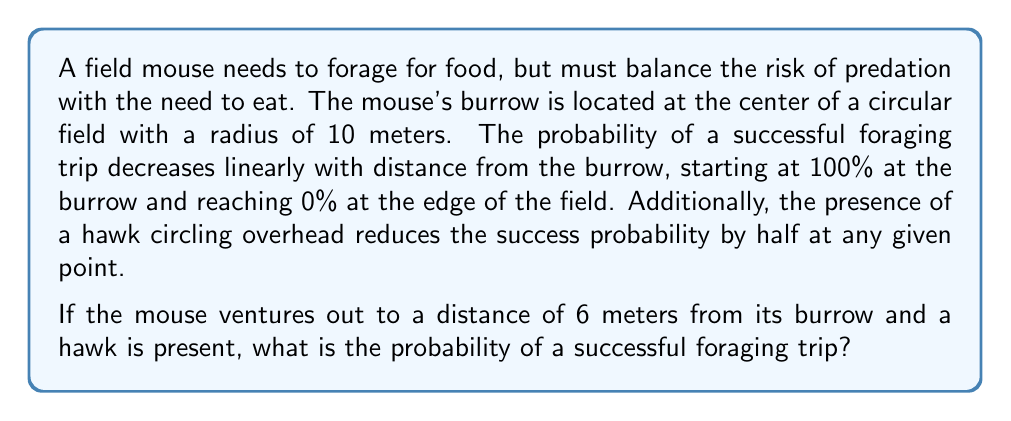Help me with this question. Let's approach this step-by-step:

1) First, we need to establish the linear relationship between distance and success probability without the hawk:

   At 0 meters (at the burrow): 100% success
   At 10 meters (edge of field): 0% success

   This forms a linear relationship that can be described by the equation:
   $$ P(success) = 1 - \frac{d}{10} $$
   where $d$ is the distance from the burrow in meters.

2) Now, let's calculate the success probability at 6 meters without the hawk:
   $$ P(success \text{ at } 6m) = 1 - \frac{6}{10} = 1 - 0.6 = 0.4 = 40\% $$

3) However, the question states that the presence of a hawk reduces the success probability by half. So we need to multiply our result by 0.5:
   $$ P(success \text{ at } 6m \text{ with hawk}) = 0.4 * 0.5 = 0.2 = 20\% $$

Therefore, the probability of a successful foraging trip at 6 meters from the burrow with a hawk present is 20%.
Answer: 20% 